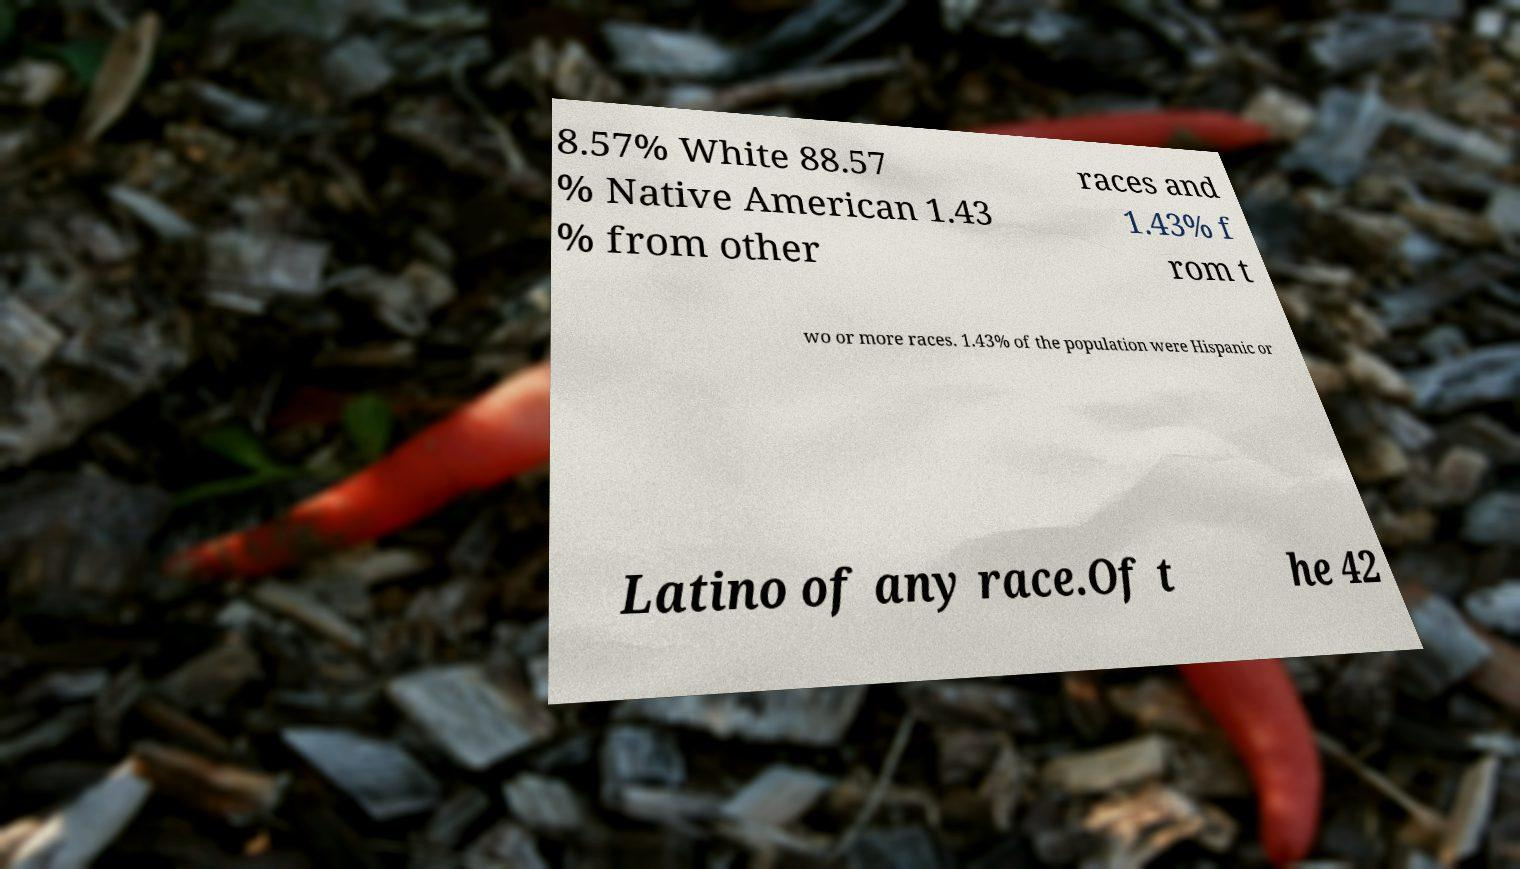Could you extract and type out the text from this image? 8.57% White 88.57 % Native American 1.43 % from other races and 1.43% f rom t wo or more races. 1.43% of the population were Hispanic or Latino of any race.Of t he 42 